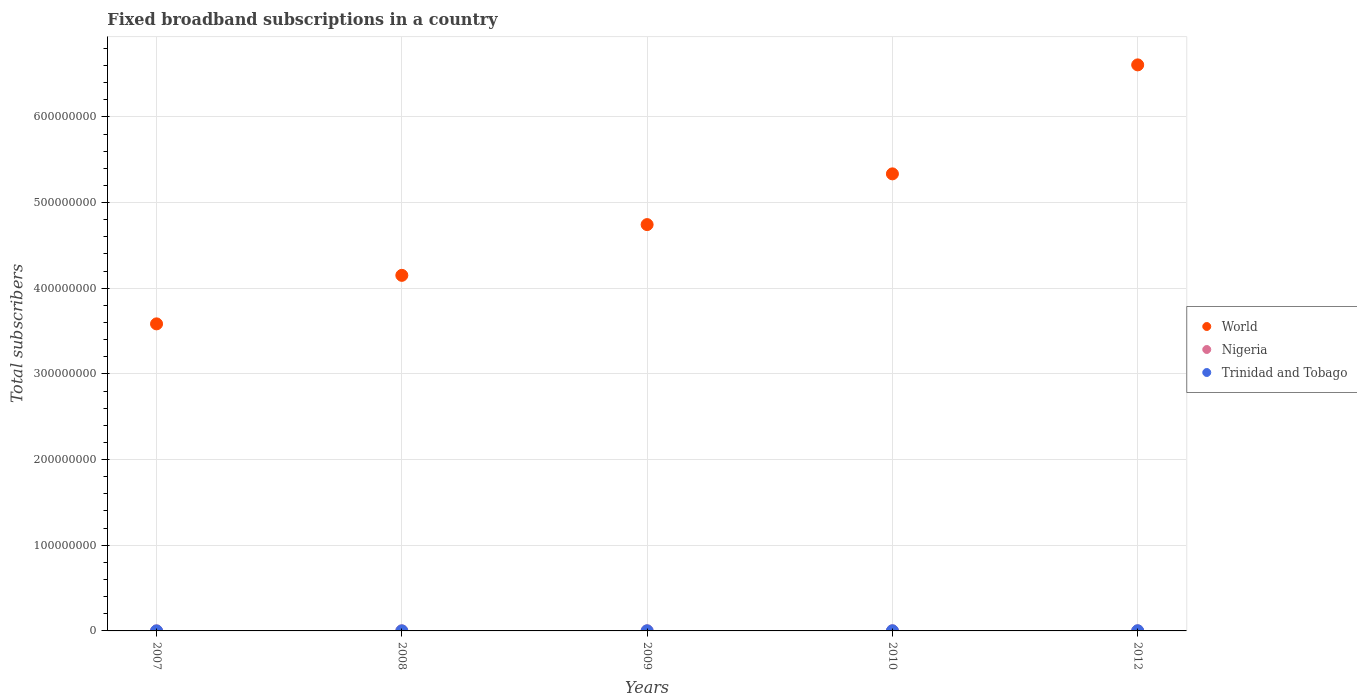Is the number of dotlines equal to the number of legend labels?
Ensure brevity in your answer.  Yes. What is the number of broadband subscriptions in Trinidad and Tobago in 2012?
Ensure brevity in your answer.  2.01e+05. Across all years, what is the maximum number of broadband subscriptions in Trinidad and Tobago?
Make the answer very short. 2.01e+05. Across all years, what is the minimum number of broadband subscriptions in Nigeria?
Provide a succinct answer. 1.43e+04. In which year was the number of broadband subscriptions in World maximum?
Your answer should be very brief. 2012. In which year was the number of broadband subscriptions in Trinidad and Tobago minimum?
Give a very brief answer. 2007. What is the total number of broadband subscriptions in Nigeria in the graph?
Your response must be concise. 3.17e+05. What is the difference between the number of broadband subscriptions in Trinidad and Tobago in 2007 and that in 2012?
Make the answer very short. -1.66e+05. What is the difference between the number of broadband subscriptions in World in 2010 and the number of broadband subscriptions in Trinidad and Tobago in 2007?
Provide a short and direct response. 5.33e+08. What is the average number of broadband subscriptions in World per year?
Ensure brevity in your answer.  4.88e+08. In the year 2008, what is the difference between the number of broadband subscriptions in Trinidad and Tobago and number of broadband subscriptions in Nigeria?
Offer a terse response. 1.77e+04. What is the ratio of the number of broadband subscriptions in Trinidad and Tobago in 2008 to that in 2012?
Keep it short and to the point. 0.42. Is the number of broadband subscriptions in Trinidad and Tobago in 2007 less than that in 2010?
Provide a short and direct response. Yes. What is the difference between the highest and the second highest number of broadband subscriptions in Nigeria?
Your response must be concise. 1.72e+04. What is the difference between the highest and the lowest number of broadband subscriptions in Trinidad and Tobago?
Offer a very short reply. 1.66e+05. Does the number of broadband subscriptions in Nigeria monotonically increase over the years?
Provide a short and direct response. No. Is the number of broadband subscriptions in Nigeria strictly greater than the number of broadband subscriptions in World over the years?
Provide a short and direct response. No. Is the number of broadband subscriptions in World strictly less than the number of broadband subscriptions in Trinidad and Tobago over the years?
Your response must be concise. No. How many years are there in the graph?
Give a very brief answer. 5. What is the difference between two consecutive major ticks on the Y-axis?
Your response must be concise. 1.00e+08. Are the values on the major ticks of Y-axis written in scientific E-notation?
Your answer should be compact. No. Does the graph contain any zero values?
Your response must be concise. No. Does the graph contain grids?
Offer a very short reply. Yes. How are the legend labels stacked?
Give a very brief answer. Vertical. What is the title of the graph?
Provide a succinct answer. Fixed broadband subscriptions in a country. What is the label or title of the Y-axis?
Provide a short and direct response. Total subscribers. What is the Total subscribers in World in 2007?
Your answer should be very brief. 3.58e+08. What is the Total subscribers of Nigeria in 2007?
Ensure brevity in your answer.  5.36e+04. What is the Total subscribers of Trinidad and Tobago in 2007?
Your answer should be very brief. 3.55e+04. What is the Total subscribers of World in 2008?
Offer a terse response. 4.15e+08. What is the Total subscribers in Nigeria in 2008?
Keep it short and to the point. 6.78e+04. What is the Total subscribers in Trinidad and Tobago in 2008?
Your answer should be very brief. 8.54e+04. What is the Total subscribers in World in 2009?
Provide a short and direct response. 4.74e+08. What is the Total subscribers in Nigeria in 2009?
Make the answer very short. 8.20e+04. What is the Total subscribers of Trinidad and Tobago in 2009?
Your answer should be compact. 1.30e+05. What is the Total subscribers in World in 2010?
Offer a terse response. 5.33e+08. What is the Total subscribers of Nigeria in 2010?
Provide a short and direct response. 9.91e+04. What is the Total subscribers in Trinidad and Tobago in 2010?
Offer a very short reply. 1.63e+05. What is the Total subscribers in World in 2012?
Ensure brevity in your answer.  6.61e+08. What is the Total subscribers of Nigeria in 2012?
Your response must be concise. 1.43e+04. What is the Total subscribers of Trinidad and Tobago in 2012?
Offer a very short reply. 2.01e+05. Across all years, what is the maximum Total subscribers in World?
Make the answer very short. 6.61e+08. Across all years, what is the maximum Total subscribers in Nigeria?
Your response must be concise. 9.91e+04. Across all years, what is the maximum Total subscribers of Trinidad and Tobago?
Your answer should be very brief. 2.01e+05. Across all years, what is the minimum Total subscribers of World?
Provide a short and direct response. 3.58e+08. Across all years, what is the minimum Total subscribers of Nigeria?
Your response must be concise. 1.43e+04. Across all years, what is the minimum Total subscribers of Trinidad and Tobago?
Your response must be concise. 3.55e+04. What is the total Total subscribers of World in the graph?
Your answer should be compact. 2.44e+09. What is the total Total subscribers of Nigeria in the graph?
Provide a succinct answer. 3.17e+05. What is the total Total subscribers of Trinidad and Tobago in the graph?
Offer a very short reply. 6.15e+05. What is the difference between the Total subscribers in World in 2007 and that in 2008?
Provide a succinct answer. -5.66e+07. What is the difference between the Total subscribers of Nigeria in 2007 and that in 2008?
Provide a short and direct response. -1.42e+04. What is the difference between the Total subscribers of Trinidad and Tobago in 2007 and that in 2008?
Your response must be concise. -5.00e+04. What is the difference between the Total subscribers in World in 2007 and that in 2009?
Make the answer very short. -1.16e+08. What is the difference between the Total subscribers in Nigeria in 2007 and that in 2009?
Keep it short and to the point. -2.84e+04. What is the difference between the Total subscribers of Trinidad and Tobago in 2007 and that in 2009?
Your answer should be very brief. -9.46e+04. What is the difference between the Total subscribers in World in 2007 and that in 2010?
Make the answer very short. -1.75e+08. What is the difference between the Total subscribers of Nigeria in 2007 and that in 2010?
Provide a succinct answer. -4.55e+04. What is the difference between the Total subscribers of Trinidad and Tobago in 2007 and that in 2010?
Ensure brevity in your answer.  -1.27e+05. What is the difference between the Total subscribers in World in 2007 and that in 2012?
Your answer should be compact. -3.02e+08. What is the difference between the Total subscribers in Nigeria in 2007 and that in 2012?
Your answer should be very brief. 3.93e+04. What is the difference between the Total subscribers in Trinidad and Tobago in 2007 and that in 2012?
Provide a succinct answer. -1.66e+05. What is the difference between the Total subscribers of World in 2008 and that in 2009?
Give a very brief answer. -5.92e+07. What is the difference between the Total subscribers of Nigeria in 2008 and that in 2009?
Ensure brevity in your answer.  -1.42e+04. What is the difference between the Total subscribers in Trinidad and Tobago in 2008 and that in 2009?
Your answer should be compact. -4.46e+04. What is the difference between the Total subscribers of World in 2008 and that in 2010?
Ensure brevity in your answer.  -1.18e+08. What is the difference between the Total subscribers in Nigeria in 2008 and that in 2010?
Your answer should be compact. -3.13e+04. What is the difference between the Total subscribers of Trinidad and Tobago in 2008 and that in 2010?
Give a very brief answer. -7.74e+04. What is the difference between the Total subscribers in World in 2008 and that in 2012?
Offer a very short reply. -2.46e+08. What is the difference between the Total subscribers in Nigeria in 2008 and that in 2012?
Provide a succinct answer. 5.35e+04. What is the difference between the Total subscribers of Trinidad and Tobago in 2008 and that in 2012?
Offer a terse response. -1.16e+05. What is the difference between the Total subscribers in World in 2009 and that in 2010?
Give a very brief answer. -5.92e+07. What is the difference between the Total subscribers in Nigeria in 2009 and that in 2010?
Your answer should be very brief. -1.72e+04. What is the difference between the Total subscribers in Trinidad and Tobago in 2009 and that in 2010?
Provide a succinct answer. -3.28e+04. What is the difference between the Total subscribers in World in 2009 and that in 2012?
Your answer should be very brief. -1.86e+08. What is the difference between the Total subscribers in Nigeria in 2009 and that in 2012?
Your answer should be very brief. 6.77e+04. What is the difference between the Total subscribers of Trinidad and Tobago in 2009 and that in 2012?
Provide a short and direct response. -7.14e+04. What is the difference between the Total subscribers in World in 2010 and that in 2012?
Offer a very short reply. -1.27e+08. What is the difference between the Total subscribers in Nigeria in 2010 and that in 2012?
Provide a short and direct response. 8.48e+04. What is the difference between the Total subscribers in Trinidad and Tobago in 2010 and that in 2012?
Your answer should be very brief. -3.86e+04. What is the difference between the Total subscribers in World in 2007 and the Total subscribers in Nigeria in 2008?
Provide a short and direct response. 3.58e+08. What is the difference between the Total subscribers of World in 2007 and the Total subscribers of Trinidad and Tobago in 2008?
Offer a terse response. 3.58e+08. What is the difference between the Total subscribers of Nigeria in 2007 and the Total subscribers of Trinidad and Tobago in 2008?
Your answer should be compact. -3.19e+04. What is the difference between the Total subscribers of World in 2007 and the Total subscribers of Nigeria in 2009?
Offer a terse response. 3.58e+08. What is the difference between the Total subscribers in World in 2007 and the Total subscribers in Trinidad and Tobago in 2009?
Offer a very short reply. 3.58e+08. What is the difference between the Total subscribers in Nigeria in 2007 and the Total subscribers in Trinidad and Tobago in 2009?
Offer a terse response. -7.65e+04. What is the difference between the Total subscribers of World in 2007 and the Total subscribers of Nigeria in 2010?
Your answer should be very brief. 3.58e+08. What is the difference between the Total subscribers in World in 2007 and the Total subscribers in Trinidad and Tobago in 2010?
Provide a short and direct response. 3.58e+08. What is the difference between the Total subscribers of Nigeria in 2007 and the Total subscribers of Trinidad and Tobago in 2010?
Your answer should be very brief. -1.09e+05. What is the difference between the Total subscribers of World in 2007 and the Total subscribers of Nigeria in 2012?
Make the answer very short. 3.58e+08. What is the difference between the Total subscribers of World in 2007 and the Total subscribers of Trinidad and Tobago in 2012?
Make the answer very short. 3.58e+08. What is the difference between the Total subscribers of Nigeria in 2007 and the Total subscribers of Trinidad and Tobago in 2012?
Offer a very short reply. -1.48e+05. What is the difference between the Total subscribers in World in 2008 and the Total subscribers in Nigeria in 2009?
Ensure brevity in your answer.  4.15e+08. What is the difference between the Total subscribers in World in 2008 and the Total subscribers in Trinidad and Tobago in 2009?
Keep it short and to the point. 4.15e+08. What is the difference between the Total subscribers in Nigeria in 2008 and the Total subscribers in Trinidad and Tobago in 2009?
Keep it short and to the point. -6.23e+04. What is the difference between the Total subscribers in World in 2008 and the Total subscribers in Nigeria in 2010?
Make the answer very short. 4.15e+08. What is the difference between the Total subscribers in World in 2008 and the Total subscribers in Trinidad and Tobago in 2010?
Make the answer very short. 4.15e+08. What is the difference between the Total subscribers of Nigeria in 2008 and the Total subscribers of Trinidad and Tobago in 2010?
Provide a succinct answer. -9.51e+04. What is the difference between the Total subscribers in World in 2008 and the Total subscribers in Nigeria in 2012?
Give a very brief answer. 4.15e+08. What is the difference between the Total subscribers in World in 2008 and the Total subscribers in Trinidad and Tobago in 2012?
Give a very brief answer. 4.15e+08. What is the difference between the Total subscribers of Nigeria in 2008 and the Total subscribers of Trinidad and Tobago in 2012?
Give a very brief answer. -1.34e+05. What is the difference between the Total subscribers in World in 2009 and the Total subscribers in Nigeria in 2010?
Your answer should be compact. 4.74e+08. What is the difference between the Total subscribers in World in 2009 and the Total subscribers in Trinidad and Tobago in 2010?
Offer a terse response. 4.74e+08. What is the difference between the Total subscribers in Nigeria in 2009 and the Total subscribers in Trinidad and Tobago in 2010?
Make the answer very short. -8.09e+04. What is the difference between the Total subscribers of World in 2009 and the Total subscribers of Nigeria in 2012?
Make the answer very short. 4.74e+08. What is the difference between the Total subscribers of World in 2009 and the Total subscribers of Trinidad and Tobago in 2012?
Make the answer very short. 4.74e+08. What is the difference between the Total subscribers of Nigeria in 2009 and the Total subscribers of Trinidad and Tobago in 2012?
Your answer should be compact. -1.19e+05. What is the difference between the Total subscribers in World in 2010 and the Total subscribers in Nigeria in 2012?
Make the answer very short. 5.33e+08. What is the difference between the Total subscribers in World in 2010 and the Total subscribers in Trinidad and Tobago in 2012?
Your answer should be very brief. 5.33e+08. What is the difference between the Total subscribers of Nigeria in 2010 and the Total subscribers of Trinidad and Tobago in 2012?
Make the answer very short. -1.02e+05. What is the average Total subscribers in World per year?
Provide a succinct answer. 4.88e+08. What is the average Total subscribers in Nigeria per year?
Keep it short and to the point. 6.33e+04. What is the average Total subscribers of Trinidad and Tobago per year?
Your answer should be very brief. 1.23e+05. In the year 2007, what is the difference between the Total subscribers of World and Total subscribers of Nigeria?
Offer a terse response. 3.58e+08. In the year 2007, what is the difference between the Total subscribers in World and Total subscribers in Trinidad and Tobago?
Provide a succinct answer. 3.58e+08. In the year 2007, what is the difference between the Total subscribers of Nigeria and Total subscribers of Trinidad and Tobago?
Keep it short and to the point. 1.81e+04. In the year 2008, what is the difference between the Total subscribers in World and Total subscribers in Nigeria?
Your response must be concise. 4.15e+08. In the year 2008, what is the difference between the Total subscribers in World and Total subscribers in Trinidad and Tobago?
Give a very brief answer. 4.15e+08. In the year 2008, what is the difference between the Total subscribers of Nigeria and Total subscribers of Trinidad and Tobago?
Your response must be concise. -1.77e+04. In the year 2009, what is the difference between the Total subscribers of World and Total subscribers of Nigeria?
Make the answer very short. 4.74e+08. In the year 2009, what is the difference between the Total subscribers of World and Total subscribers of Trinidad and Tobago?
Provide a short and direct response. 4.74e+08. In the year 2009, what is the difference between the Total subscribers in Nigeria and Total subscribers in Trinidad and Tobago?
Your response must be concise. -4.81e+04. In the year 2010, what is the difference between the Total subscribers of World and Total subscribers of Nigeria?
Your response must be concise. 5.33e+08. In the year 2010, what is the difference between the Total subscribers in World and Total subscribers in Trinidad and Tobago?
Offer a very short reply. 5.33e+08. In the year 2010, what is the difference between the Total subscribers in Nigeria and Total subscribers in Trinidad and Tobago?
Your answer should be very brief. -6.37e+04. In the year 2012, what is the difference between the Total subscribers in World and Total subscribers in Nigeria?
Your answer should be compact. 6.61e+08. In the year 2012, what is the difference between the Total subscribers of World and Total subscribers of Trinidad and Tobago?
Your answer should be compact. 6.60e+08. In the year 2012, what is the difference between the Total subscribers of Nigeria and Total subscribers of Trinidad and Tobago?
Ensure brevity in your answer.  -1.87e+05. What is the ratio of the Total subscribers in World in 2007 to that in 2008?
Offer a very short reply. 0.86. What is the ratio of the Total subscribers of Nigeria in 2007 to that in 2008?
Make the answer very short. 0.79. What is the ratio of the Total subscribers in Trinidad and Tobago in 2007 to that in 2008?
Provide a succinct answer. 0.42. What is the ratio of the Total subscribers in World in 2007 to that in 2009?
Give a very brief answer. 0.76. What is the ratio of the Total subscribers of Nigeria in 2007 to that in 2009?
Give a very brief answer. 0.65. What is the ratio of the Total subscribers of Trinidad and Tobago in 2007 to that in 2009?
Offer a very short reply. 0.27. What is the ratio of the Total subscribers in World in 2007 to that in 2010?
Your response must be concise. 0.67. What is the ratio of the Total subscribers of Nigeria in 2007 to that in 2010?
Give a very brief answer. 0.54. What is the ratio of the Total subscribers of Trinidad and Tobago in 2007 to that in 2010?
Your response must be concise. 0.22. What is the ratio of the Total subscribers of World in 2007 to that in 2012?
Provide a succinct answer. 0.54. What is the ratio of the Total subscribers in Nigeria in 2007 to that in 2012?
Provide a short and direct response. 3.75. What is the ratio of the Total subscribers in Trinidad and Tobago in 2007 to that in 2012?
Offer a terse response. 0.18. What is the ratio of the Total subscribers of World in 2008 to that in 2009?
Offer a very short reply. 0.88. What is the ratio of the Total subscribers in Nigeria in 2008 to that in 2009?
Provide a short and direct response. 0.83. What is the ratio of the Total subscribers in Trinidad and Tobago in 2008 to that in 2009?
Give a very brief answer. 0.66. What is the ratio of the Total subscribers in World in 2008 to that in 2010?
Provide a short and direct response. 0.78. What is the ratio of the Total subscribers in Nigeria in 2008 to that in 2010?
Make the answer very short. 0.68. What is the ratio of the Total subscribers in Trinidad and Tobago in 2008 to that in 2010?
Make the answer very short. 0.52. What is the ratio of the Total subscribers of World in 2008 to that in 2012?
Offer a very short reply. 0.63. What is the ratio of the Total subscribers in Nigeria in 2008 to that in 2012?
Make the answer very short. 4.75. What is the ratio of the Total subscribers in Trinidad and Tobago in 2008 to that in 2012?
Ensure brevity in your answer.  0.42. What is the ratio of the Total subscribers in World in 2009 to that in 2010?
Your answer should be compact. 0.89. What is the ratio of the Total subscribers of Nigeria in 2009 to that in 2010?
Provide a short and direct response. 0.83. What is the ratio of the Total subscribers of Trinidad and Tobago in 2009 to that in 2010?
Your answer should be compact. 0.8. What is the ratio of the Total subscribers of World in 2009 to that in 2012?
Offer a terse response. 0.72. What is the ratio of the Total subscribers in Nigeria in 2009 to that in 2012?
Provide a succinct answer. 5.74. What is the ratio of the Total subscribers in Trinidad and Tobago in 2009 to that in 2012?
Your answer should be very brief. 0.65. What is the ratio of the Total subscribers of World in 2010 to that in 2012?
Ensure brevity in your answer.  0.81. What is the ratio of the Total subscribers of Nigeria in 2010 to that in 2012?
Your answer should be compact. 6.94. What is the ratio of the Total subscribers in Trinidad and Tobago in 2010 to that in 2012?
Your answer should be compact. 0.81. What is the difference between the highest and the second highest Total subscribers of World?
Offer a very short reply. 1.27e+08. What is the difference between the highest and the second highest Total subscribers in Nigeria?
Ensure brevity in your answer.  1.72e+04. What is the difference between the highest and the second highest Total subscribers of Trinidad and Tobago?
Give a very brief answer. 3.86e+04. What is the difference between the highest and the lowest Total subscribers of World?
Your response must be concise. 3.02e+08. What is the difference between the highest and the lowest Total subscribers in Nigeria?
Give a very brief answer. 8.48e+04. What is the difference between the highest and the lowest Total subscribers of Trinidad and Tobago?
Ensure brevity in your answer.  1.66e+05. 